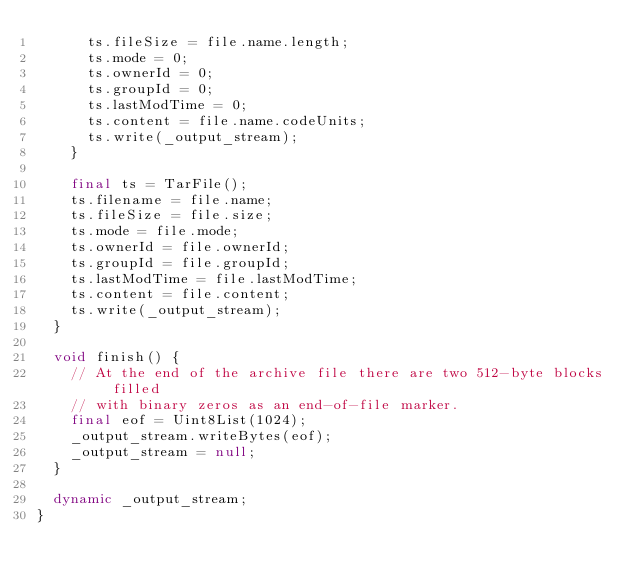<code> <loc_0><loc_0><loc_500><loc_500><_Dart_>      ts.fileSize = file.name.length;
      ts.mode = 0;
      ts.ownerId = 0;
      ts.groupId = 0;
      ts.lastModTime = 0;
      ts.content = file.name.codeUnits;
      ts.write(_output_stream);
    }

    final ts = TarFile();
    ts.filename = file.name;
    ts.fileSize = file.size;
    ts.mode = file.mode;
    ts.ownerId = file.ownerId;
    ts.groupId = file.groupId;
    ts.lastModTime = file.lastModTime;
    ts.content = file.content;
    ts.write(_output_stream);
  }

  void finish() {
    // At the end of the archive file there are two 512-byte blocks filled
    // with binary zeros as an end-of-file marker.
    final eof = Uint8List(1024);
    _output_stream.writeBytes(eof);
    _output_stream = null;
  }

  dynamic _output_stream;
}
</code> 